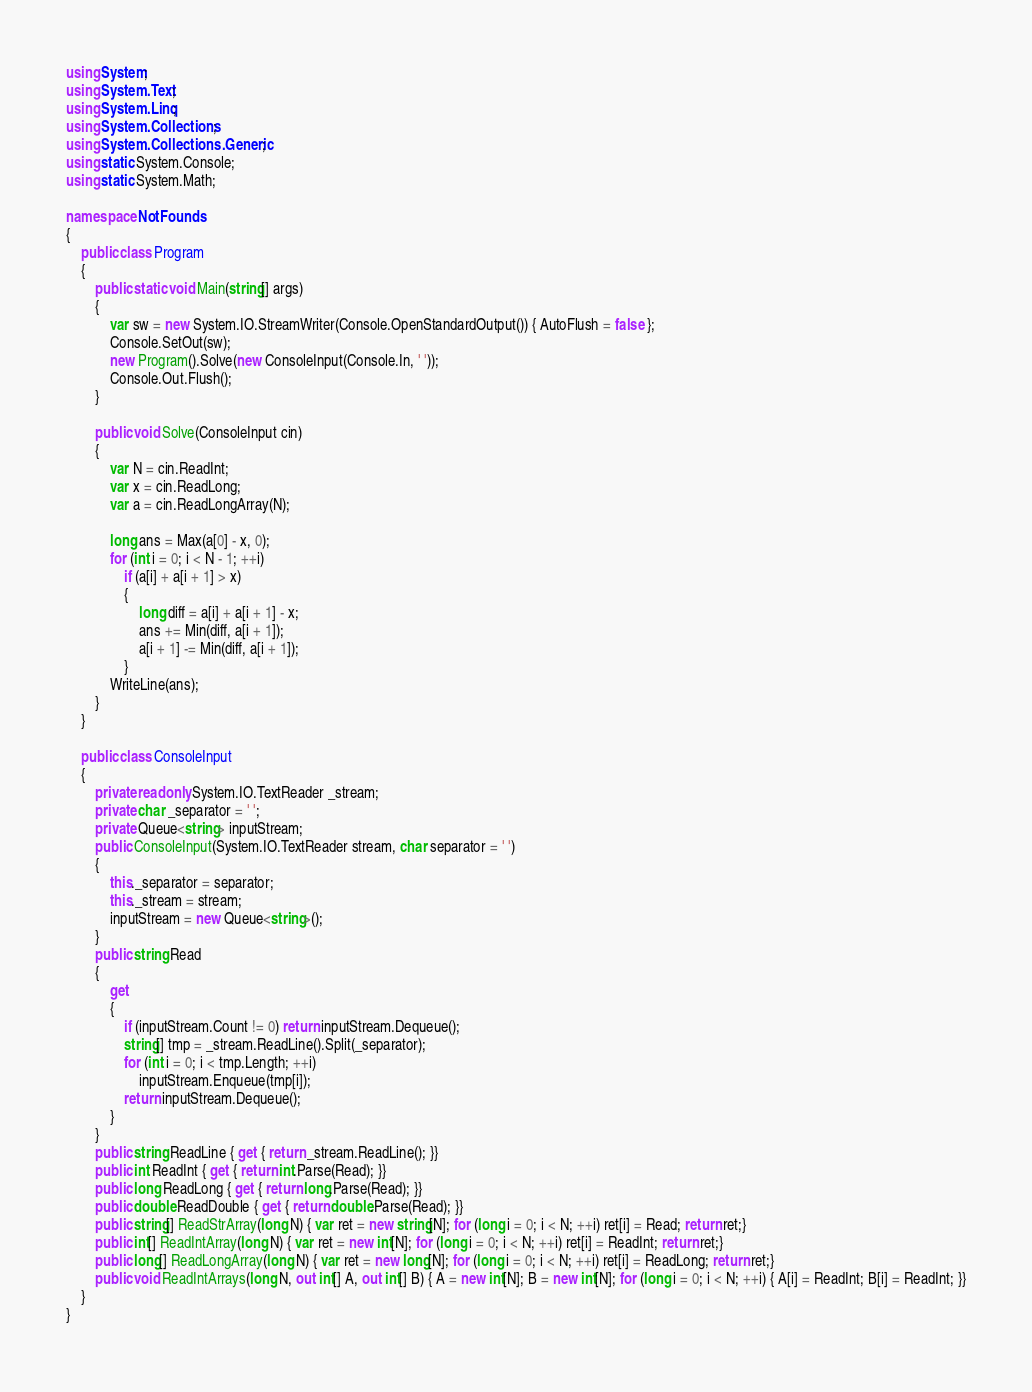Convert code to text. <code><loc_0><loc_0><loc_500><loc_500><_C#_>using System;
using System.Text;
using System.Linq;
using System.Collections;
using System.Collections.Generic;
using static System.Console;
using static System.Math;

namespace NotFounds
{
    public class Program
    {
        public static void Main(string[] args)
        {
            var sw = new System.IO.StreamWriter(Console.OpenStandardOutput()) { AutoFlush = false };
            Console.SetOut(sw);
            new Program().Solve(new ConsoleInput(Console.In, ' '));
            Console.Out.Flush();
        }

        public void Solve(ConsoleInput cin)
        {
            var N = cin.ReadInt;
            var x = cin.ReadLong;
            var a = cin.ReadLongArray(N);

            long ans = Max(a[0] - x, 0);
            for (int i = 0; i < N - 1; ++i)
                if (a[i] + a[i + 1] > x)
                {
                    long diff = a[i] + a[i + 1] - x;
                    ans += Min(diff, a[i + 1]);
                    a[i + 1] -= Min(diff, a[i + 1]);
                }
            WriteLine(ans);
        }
    }

    public class ConsoleInput
    {
        private readonly System.IO.TextReader _stream;
        private char _separator = ' ';
        private Queue<string> inputStream;
        public ConsoleInput(System.IO.TextReader stream, char separator = ' ')
        {
            this._separator = separator;
            this._stream = stream;
            inputStream = new Queue<string>();
        }
        public string Read
        {
            get
            {
                if (inputStream.Count != 0) return inputStream.Dequeue();
                string[] tmp = _stream.ReadLine().Split(_separator);
                for (int i = 0; i < tmp.Length; ++i)
                    inputStream.Enqueue(tmp[i]);
                return inputStream.Dequeue();
            }
        }
        public string ReadLine { get { return _stream.ReadLine(); }}
        public int ReadInt { get { return int.Parse(Read); }}
        public long ReadLong { get { return long.Parse(Read); }}
        public double ReadDouble { get { return double.Parse(Read); }}
        public string[] ReadStrArray(long N) { var ret = new string[N]; for (long i = 0; i < N; ++i) ret[i] = Read; return ret;}
        public int[] ReadIntArray(long N) { var ret = new int[N]; for (long i = 0; i < N; ++i) ret[i] = ReadInt; return ret;}
        public long[] ReadLongArray(long N) { var ret = new long[N]; for (long i = 0; i < N; ++i) ret[i] = ReadLong; return ret;}
        public void ReadIntArrays(long N, out int[] A, out int[] B) { A = new int[N]; B = new int[N]; for (long i = 0; i < N; ++i) { A[i] = ReadInt; B[i] = ReadInt; }}
    }
}
</code> 